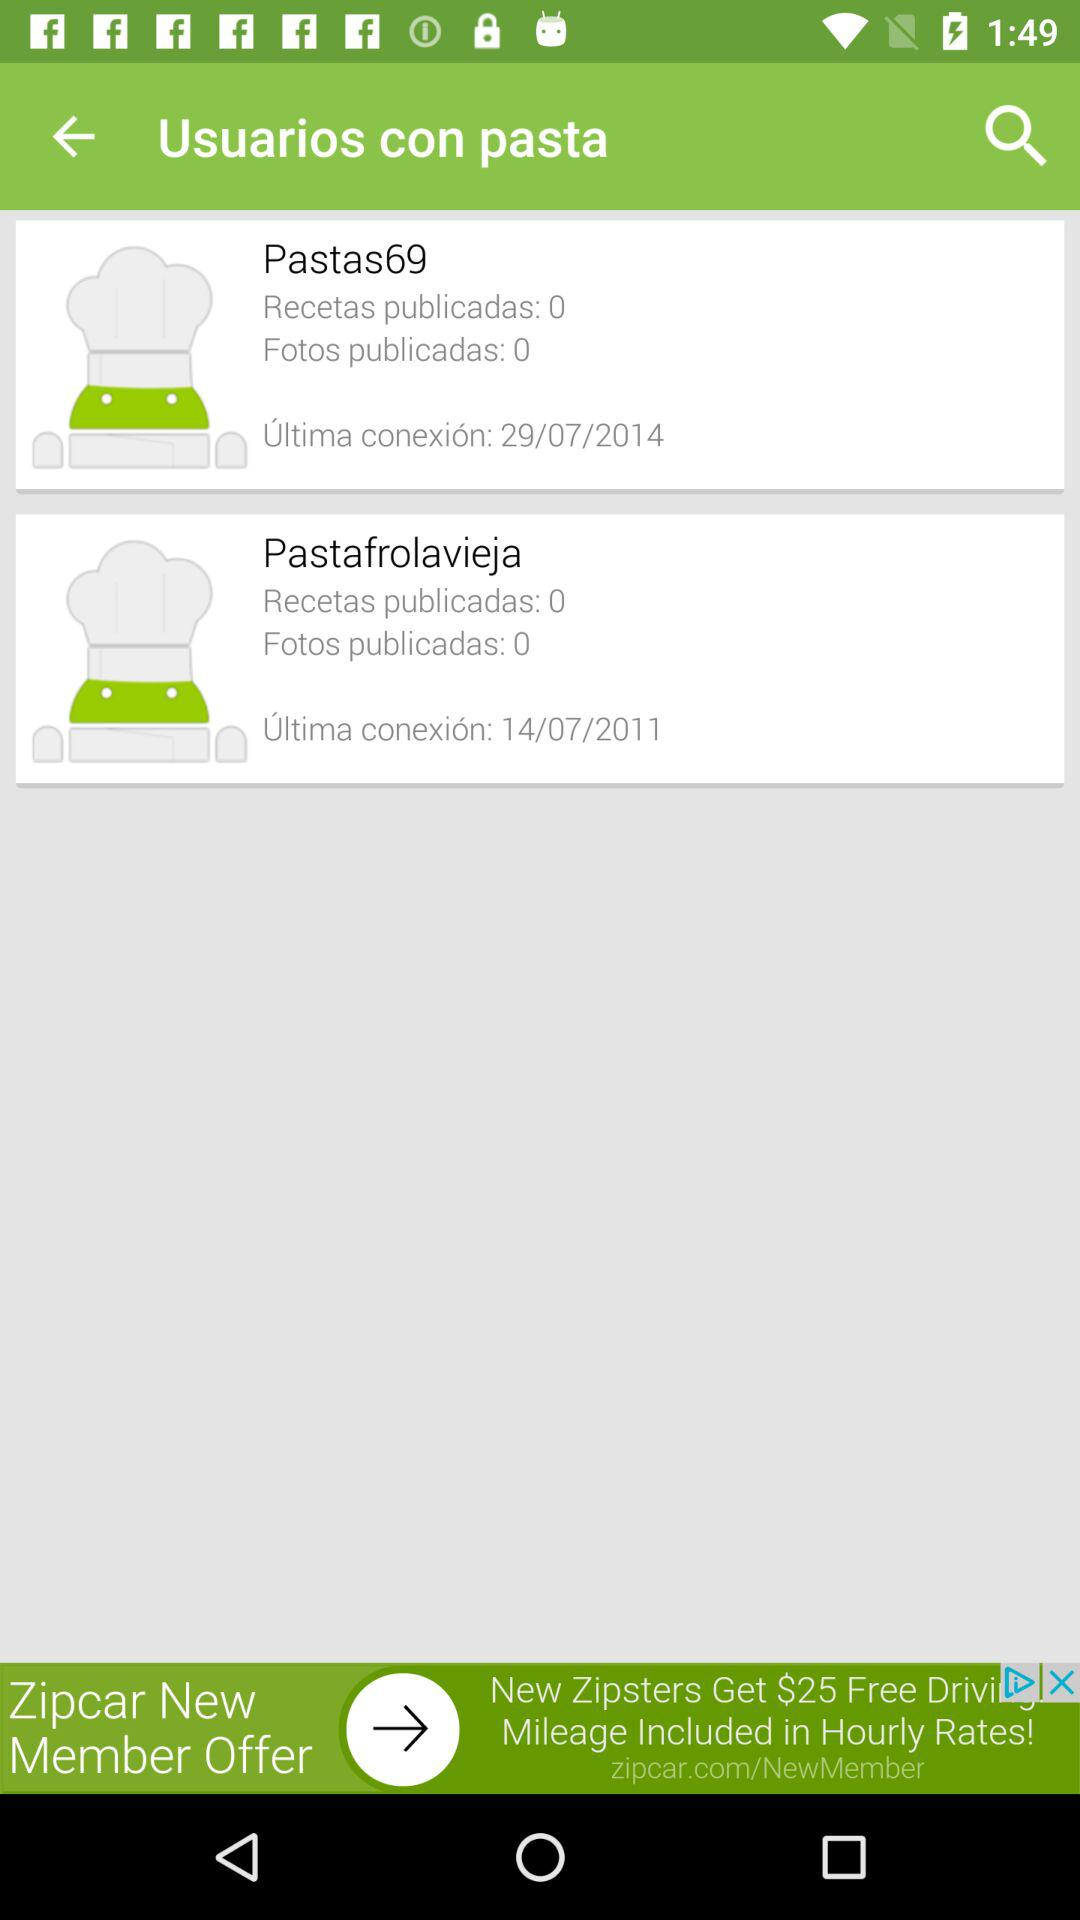How many users are there with pasta in their name?
Answer the question using a single word or phrase. 2 